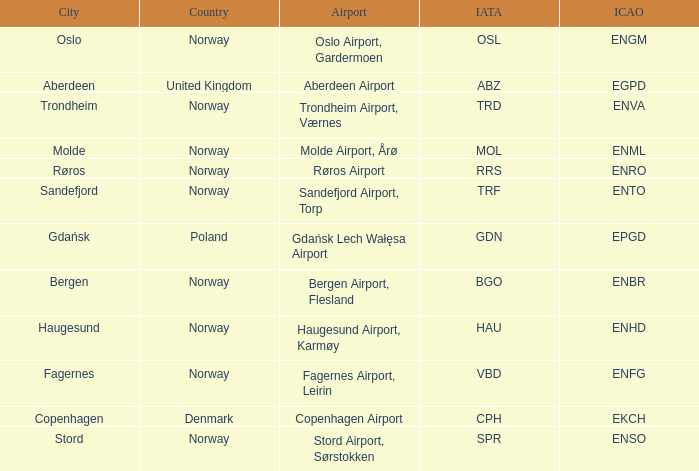What is th IATA for Norway with an ICAO of ENTO? TRF. 